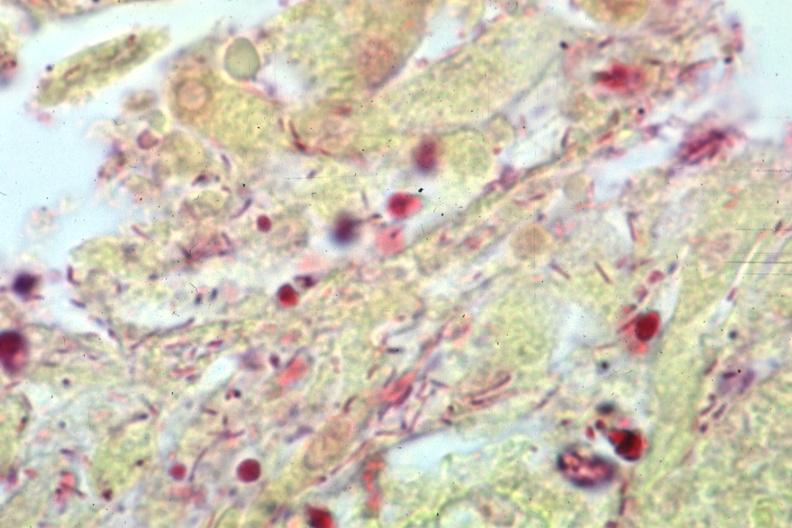does this image show gram stain gram negative bacteria?
Answer the question using a single word or phrase. Yes 